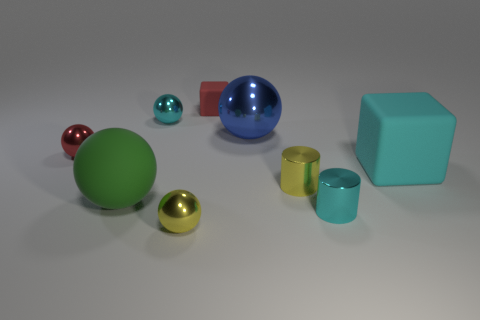There is a small cylinder that is right of the yellow cylinder; does it have the same color as the large rubber block?
Keep it short and to the point. Yes. There is a rubber block that is behind the large cyan rubber object; is there a thing that is on the left side of it?
Provide a succinct answer. Yes. Are there fewer objects in front of the blue thing than objects in front of the red rubber cube?
Your answer should be compact. Yes. How big is the red thing that is behind the small red thing that is to the left of the matte object that is behind the cyan matte object?
Offer a terse response. Small. There is a yellow object that is in front of the yellow cylinder; does it have the same size as the tiny red block?
Ensure brevity in your answer.  Yes. How many other things are made of the same material as the yellow cylinder?
Your answer should be very brief. 5. Are there more red rubber cubes than red objects?
Offer a terse response. No. What is the material of the large object to the left of the cyan metallic object on the left side of the cyan object that is in front of the matte sphere?
Offer a terse response. Rubber. Is there a object of the same color as the big block?
Offer a terse response. Yes. There is a cyan object that is the same size as the blue shiny ball; what shape is it?
Provide a short and direct response. Cube. 